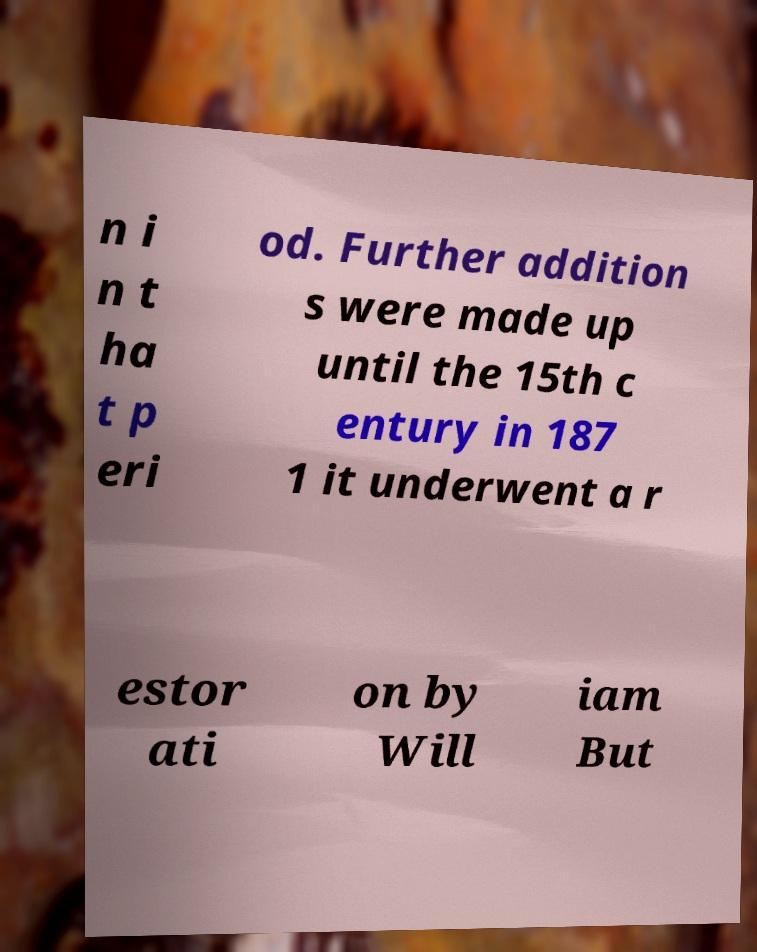Please identify and transcribe the text found in this image. n i n t ha t p eri od. Further addition s were made up until the 15th c entury in 187 1 it underwent a r estor ati on by Will iam But 